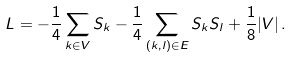<formula> <loc_0><loc_0><loc_500><loc_500>L = - \frac { 1 } { 4 } \sum _ { k \in V } S _ { k } - \frac { 1 } { 4 } \sum _ { ( k , l ) \in E } S _ { k } S _ { l } + \frac { 1 } { 8 } | V | \, .</formula> 